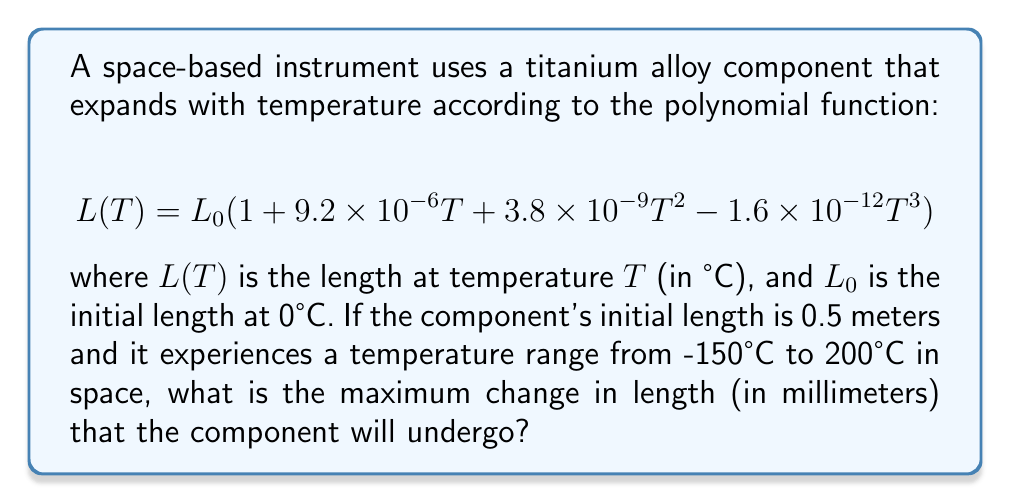Can you solve this math problem? To solve this problem, we need to follow these steps:

1) First, we need to find the length at both temperature extremes:
   
   At -150°C: 
   $$L(-150) = 0.5(1 + 9.2 \times 10^{-6}(-150) + 3.8 \times 10^{-9}(-150)^2 - 1.6 \times 10^{-12}(-150)^3)$$
   
   At 200°C:
   $$L(200) = 0.5(1 + 9.2 \times 10^{-6}(200) + 3.8 \times 10^{-9}(200)^2 - 1.6 \times 10^{-12}(200)^3)$$

2) Let's calculate these values:

   $L(-150) = 0.5(1 - 0.00138 + 0.000085500 + 0.000054000) = 0.5(0.999759) = 0.4998795$ meters

   $L(200) = 0.5(1 + 0.00184 + 0.000152000 - 0.000012800) = 0.5(1.001979) = 0.5009895$ meters

3) The change in length is the difference between these two values:

   $\Delta L = L(200) - L(-150) = 0.5009895 - 0.4998795 = 0.0011100$ meters

4) Convert this to millimeters:

   $0.0011100$ meters $= 1.1100$ millimeters

Therefore, the maximum change in length is 1.1100 millimeters.
Answer: 1.1100 mm 